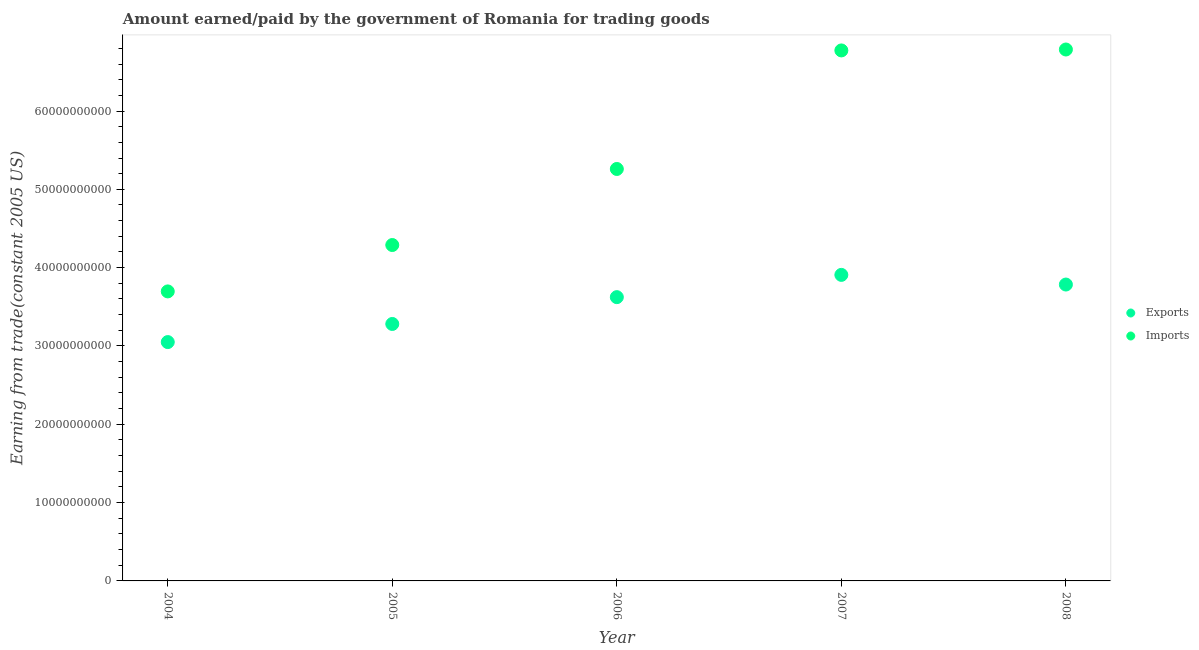How many different coloured dotlines are there?
Provide a succinct answer. 2. What is the amount paid for imports in 2007?
Ensure brevity in your answer.  6.77e+1. Across all years, what is the maximum amount paid for imports?
Offer a very short reply. 6.79e+1. Across all years, what is the minimum amount paid for imports?
Give a very brief answer. 3.70e+1. In which year was the amount earned from exports maximum?
Your answer should be very brief. 2007. What is the total amount earned from exports in the graph?
Your answer should be very brief. 1.76e+11. What is the difference between the amount earned from exports in 2004 and that in 2007?
Ensure brevity in your answer.  -8.58e+09. What is the difference between the amount paid for imports in 2007 and the amount earned from exports in 2008?
Your answer should be compact. 2.99e+1. What is the average amount paid for imports per year?
Offer a very short reply. 5.36e+1. In the year 2006, what is the difference between the amount earned from exports and amount paid for imports?
Provide a short and direct response. -1.64e+1. What is the ratio of the amount paid for imports in 2006 to that in 2007?
Keep it short and to the point. 0.78. Is the amount earned from exports in 2005 less than that in 2007?
Make the answer very short. Yes. Is the difference between the amount earned from exports in 2007 and 2008 greater than the difference between the amount paid for imports in 2007 and 2008?
Offer a terse response. Yes. What is the difference between the highest and the second highest amount paid for imports?
Offer a very short reply. 1.19e+08. What is the difference between the highest and the lowest amount paid for imports?
Offer a very short reply. 3.09e+1. In how many years, is the amount earned from exports greater than the average amount earned from exports taken over all years?
Offer a very short reply. 3. Is the amount earned from exports strictly less than the amount paid for imports over the years?
Provide a succinct answer. Yes. How many dotlines are there?
Provide a short and direct response. 2. What is the difference between two consecutive major ticks on the Y-axis?
Make the answer very short. 1.00e+1. Are the values on the major ticks of Y-axis written in scientific E-notation?
Provide a short and direct response. No. Where does the legend appear in the graph?
Your response must be concise. Center right. What is the title of the graph?
Keep it short and to the point. Amount earned/paid by the government of Romania for trading goods. Does "Official aid received" appear as one of the legend labels in the graph?
Provide a short and direct response. No. What is the label or title of the X-axis?
Make the answer very short. Year. What is the label or title of the Y-axis?
Offer a terse response. Earning from trade(constant 2005 US). What is the Earning from trade(constant 2005 US) of Exports in 2004?
Offer a very short reply. 3.05e+1. What is the Earning from trade(constant 2005 US) of Imports in 2004?
Provide a short and direct response. 3.70e+1. What is the Earning from trade(constant 2005 US) in Exports in 2005?
Your answer should be very brief. 3.28e+1. What is the Earning from trade(constant 2005 US) of Imports in 2005?
Offer a very short reply. 4.29e+1. What is the Earning from trade(constant 2005 US) in Exports in 2006?
Your response must be concise. 3.62e+1. What is the Earning from trade(constant 2005 US) of Imports in 2006?
Your response must be concise. 5.26e+1. What is the Earning from trade(constant 2005 US) of Exports in 2007?
Give a very brief answer. 3.91e+1. What is the Earning from trade(constant 2005 US) in Imports in 2007?
Your answer should be compact. 6.77e+1. What is the Earning from trade(constant 2005 US) of Exports in 2008?
Your response must be concise. 3.78e+1. What is the Earning from trade(constant 2005 US) of Imports in 2008?
Offer a very short reply. 6.79e+1. Across all years, what is the maximum Earning from trade(constant 2005 US) in Exports?
Provide a short and direct response. 3.91e+1. Across all years, what is the maximum Earning from trade(constant 2005 US) in Imports?
Provide a short and direct response. 6.79e+1. Across all years, what is the minimum Earning from trade(constant 2005 US) of Exports?
Your response must be concise. 3.05e+1. Across all years, what is the minimum Earning from trade(constant 2005 US) in Imports?
Offer a terse response. 3.70e+1. What is the total Earning from trade(constant 2005 US) in Exports in the graph?
Keep it short and to the point. 1.76e+11. What is the total Earning from trade(constant 2005 US) of Imports in the graph?
Your answer should be compact. 2.68e+11. What is the difference between the Earning from trade(constant 2005 US) in Exports in 2004 and that in 2005?
Your answer should be very brief. -2.31e+09. What is the difference between the Earning from trade(constant 2005 US) in Imports in 2004 and that in 2005?
Keep it short and to the point. -5.92e+09. What is the difference between the Earning from trade(constant 2005 US) in Exports in 2004 and that in 2006?
Ensure brevity in your answer.  -5.74e+09. What is the difference between the Earning from trade(constant 2005 US) of Imports in 2004 and that in 2006?
Make the answer very short. -1.56e+1. What is the difference between the Earning from trade(constant 2005 US) of Exports in 2004 and that in 2007?
Your answer should be compact. -8.58e+09. What is the difference between the Earning from trade(constant 2005 US) in Imports in 2004 and that in 2007?
Offer a terse response. -3.08e+1. What is the difference between the Earning from trade(constant 2005 US) of Exports in 2004 and that in 2008?
Keep it short and to the point. -7.35e+09. What is the difference between the Earning from trade(constant 2005 US) of Imports in 2004 and that in 2008?
Provide a short and direct response. -3.09e+1. What is the difference between the Earning from trade(constant 2005 US) in Exports in 2005 and that in 2006?
Provide a short and direct response. -3.43e+09. What is the difference between the Earning from trade(constant 2005 US) in Imports in 2005 and that in 2006?
Give a very brief answer. -9.71e+09. What is the difference between the Earning from trade(constant 2005 US) in Exports in 2005 and that in 2007?
Provide a short and direct response. -6.27e+09. What is the difference between the Earning from trade(constant 2005 US) in Imports in 2005 and that in 2007?
Offer a very short reply. -2.48e+1. What is the difference between the Earning from trade(constant 2005 US) of Exports in 2005 and that in 2008?
Offer a very short reply. -5.03e+09. What is the difference between the Earning from trade(constant 2005 US) of Imports in 2005 and that in 2008?
Provide a succinct answer. -2.50e+1. What is the difference between the Earning from trade(constant 2005 US) in Exports in 2006 and that in 2007?
Your response must be concise. -2.84e+09. What is the difference between the Earning from trade(constant 2005 US) of Imports in 2006 and that in 2007?
Offer a terse response. -1.51e+1. What is the difference between the Earning from trade(constant 2005 US) in Exports in 2006 and that in 2008?
Offer a very short reply. -1.61e+09. What is the difference between the Earning from trade(constant 2005 US) of Imports in 2006 and that in 2008?
Keep it short and to the point. -1.53e+1. What is the difference between the Earning from trade(constant 2005 US) in Exports in 2007 and that in 2008?
Provide a short and direct response. 1.23e+09. What is the difference between the Earning from trade(constant 2005 US) of Imports in 2007 and that in 2008?
Your response must be concise. -1.19e+08. What is the difference between the Earning from trade(constant 2005 US) of Exports in 2004 and the Earning from trade(constant 2005 US) of Imports in 2005?
Ensure brevity in your answer.  -1.24e+1. What is the difference between the Earning from trade(constant 2005 US) of Exports in 2004 and the Earning from trade(constant 2005 US) of Imports in 2006?
Provide a succinct answer. -2.21e+1. What is the difference between the Earning from trade(constant 2005 US) in Exports in 2004 and the Earning from trade(constant 2005 US) in Imports in 2007?
Keep it short and to the point. -3.72e+1. What is the difference between the Earning from trade(constant 2005 US) of Exports in 2004 and the Earning from trade(constant 2005 US) of Imports in 2008?
Your response must be concise. -3.74e+1. What is the difference between the Earning from trade(constant 2005 US) in Exports in 2005 and the Earning from trade(constant 2005 US) in Imports in 2006?
Provide a short and direct response. -1.98e+1. What is the difference between the Earning from trade(constant 2005 US) in Exports in 2005 and the Earning from trade(constant 2005 US) in Imports in 2007?
Your response must be concise. -3.49e+1. What is the difference between the Earning from trade(constant 2005 US) of Exports in 2005 and the Earning from trade(constant 2005 US) of Imports in 2008?
Keep it short and to the point. -3.50e+1. What is the difference between the Earning from trade(constant 2005 US) in Exports in 2006 and the Earning from trade(constant 2005 US) in Imports in 2007?
Ensure brevity in your answer.  -3.15e+1. What is the difference between the Earning from trade(constant 2005 US) in Exports in 2006 and the Earning from trade(constant 2005 US) in Imports in 2008?
Your answer should be very brief. -3.16e+1. What is the difference between the Earning from trade(constant 2005 US) in Exports in 2007 and the Earning from trade(constant 2005 US) in Imports in 2008?
Keep it short and to the point. -2.88e+1. What is the average Earning from trade(constant 2005 US) in Exports per year?
Offer a terse response. 3.53e+1. What is the average Earning from trade(constant 2005 US) of Imports per year?
Provide a succinct answer. 5.36e+1. In the year 2004, what is the difference between the Earning from trade(constant 2005 US) of Exports and Earning from trade(constant 2005 US) of Imports?
Provide a succinct answer. -6.47e+09. In the year 2005, what is the difference between the Earning from trade(constant 2005 US) in Exports and Earning from trade(constant 2005 US) in Imports?
Provide a short and direct response. -1.01e+1. In the year 2006, what is the difference between the Earning from trade(constant 2005 US) in Exports and Earning from trade(constant 2005 US) in Imports?
Provide a succinct answer. -1.64e+1. In the year 2007, what is the difference between the Earning from trade(constant 2005 US) in Exports and Earning from trade(constant 2005 US) in Imports?
Provide a short and direct response. -2.87e+1. In the year 2008, what is the difference between the Earning from trade(constant 2005 US) of Exports and Earning from trade(constant 2005 US) of Imports?
Your answer should be compact. -3.00e+1. What is the ratio of the Earning from trade(constant 2005 US) of Exports in 2004 to that in 2005?
Ensure brevity in your answer.  0.93. What is the ratio of the Earning from trade(constant 2005 US) of Imports in 2004 to that in 2005?
Your response must be concise. 0.86. What is the ratio of the Earning from trade(constant 2005 US) of Exports in 2004 to that in 2006?
Give a very brief answer. 0.84. What is the ratio of the Earning from trade(constant 2005 US) in Imports in 2004 to that in 2006?
Ensure brevity in your answer.  0.7. What is the ratio of the Earning from trade(constant 2005 US) in Exports in 2004 to that in 2007?
Provide a succinct answer. 0.78. What is the ratio of the Earning from trade(constant 2005 US) in Imports in 2004 to that in 2007?
Your answer should be compact. 0.55. What is the ratio of the Earning from trade(constant 2005 US) of Exports in 2004 to that in 2008?
Your answer should be very brief. 0.81. What is the ratio of the Earning from trade(constant 2005 US) of Imports in 2004 to that in 2008?
Offer a very short reply. 0.54. What is the ratio of the Earning from trade(constant 2005 US) of Exports in 2005 to that in 2006?
Offer a very short reply. 0.91. What is the ratio of the Earning from trade(constant 2005 US) in Imports in 2005 to that in 2006?
Keep it short and to the point. 0.82. What is the ratio of the Earning from trade(constant 2005 US) in Exports in 2005 to that in 2007?
Your answer should be compact. 0.84. What is the ratio of the Earning from trade(constant 2005 US) of Imports in 2005 to that in 2007?
Provide a short and direct response. 0.63. What is the ratio of the Earning from trade(constant 2005 US) in Exports in 2005 to that in 2008?
Provide a short and direct response. 0.87. What is the ratio of the Earning from trade(constant 2005 US) in Imports in 2005 to that in 2008?
Your answer should be compact. 0.63. What is the ratio of the Earning from trade(constant 2005 US) in Exports in 2006 to that in 2007?
Your response must be concise. 0.93. What is the ratio of the Earning from trade(constant 2005 US) of Imports in 2006 to that in 2007?
Offer a terse response. 0.78. What is the ratio of the Earning from trade(constant 2005 US) of Exports in 2006 to that in 2008?
Give a very brief answer. 0.96. What is the ratio of the Earning from trade(constant 2005 US) of Imports in 2006 to that in 2008?
Keep it short and to the point. 0.78. What is the ratio of the Earning from trade(constant 2005 US) in Exports in 2007 to that in 2008?
Ensure brevity in your answer.  1.03. What is the ratio of the Earning from trade(constant 2005 US) in Imports in 2007 to that in 2008?
Provide a succinct answer. 1. What is the difference between the highest and the second highest Earning from trade(constant 2005 US) in Exports?
Your answer should be very brief. 1.23e+09. What is the difference between the highest and the second highest Earning from trade(constant 2005 US) of Imports?
Your answer should be very brief. 1.19e+08. What is the difference between the highest and the lowest Earning from trade(constant 2005 US) of Exports?
Your answer should be compact. 8.58e+09. What is the difference between the highest and the lowest Earning from trade(constant 2005 US) of Imports?
Your response must be concise. 3.09e+1. 